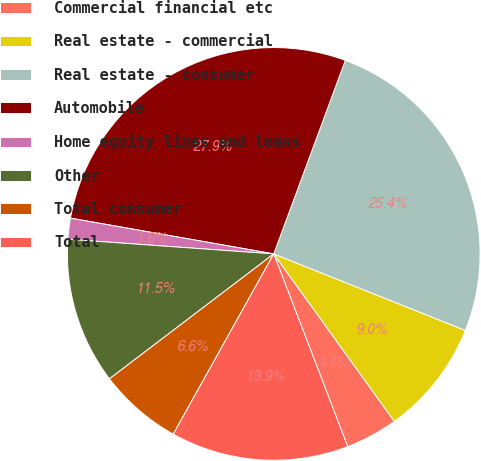<chart> <loc_0><loc_0><loc_500><loc_500><pie_chart><fcel>Commercial financial etc<fcel>Real estate - commercial<fcel>Real estate - consumer<fcel>Automobile<fcel>Home equity lines and loans<fcel>Other<fcel>Total consumer<fcel>Total<nl><fcel>4.1%<fcel>9.02%<fcel>25.41%<fcel>27.87%<fcel>1.64%<fcel>11.48%<fcel>6.56%<fcel>13.93%<nl></chart> 